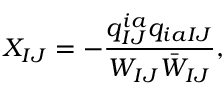<formula> <loc_0><loc_0><loc_500><loc_500>X _ { I J } = - \frac { q _ { I J } ^ { i a } q _ { i a I J } } { W _ { I J } \bar { W } _ { I J } } ,</formula> 